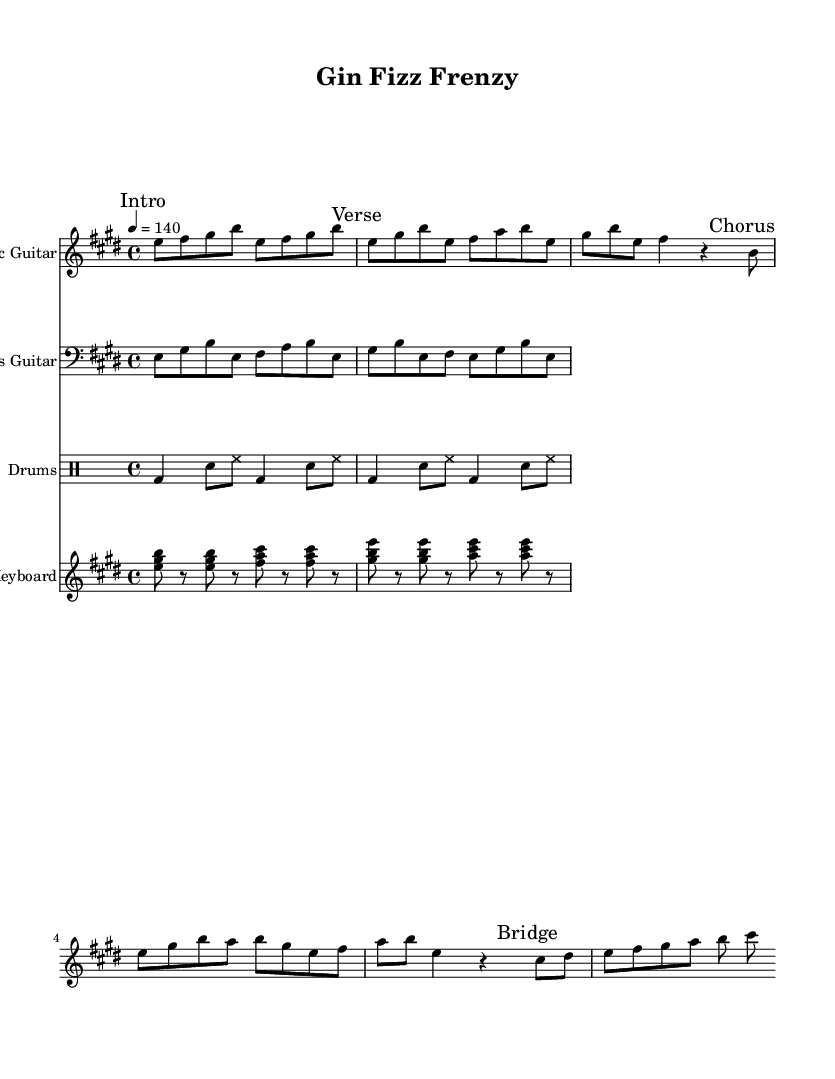What is the key signature of this music? The key signature is indicated before the staff and shows the presence of four sharps, meaning it is E major.
Answer: E major What is the time signature of this music? The time signature appears at the beginning of the score and is expressed as a fraction, indicating four beats in a measure, which is 4/4.
Answer: 4/4 What is the tempo marking of this piece? The tempo marking appears in the header section as "4 = 140," indicating a speed of 140 beats per minute.
Answer: 140 How many distinct sections are there in this piece? The music contains four distinct marked sections: Intro, Verse, Chorus, and Bridge, as indicated in the guitar part annotations.
Answer: Four What is the tempo indication of the Chorus section? The tempo remains constant at 140 beats per minute throughout the piece; the chorus section does not change this tempo.
Answer: 140 What instrument is primarily featured in the melody? The melody is primarily carried out by the Electric Guitar part, as indicated by the staff heading.
Answer: Electric Guitar What type of rhythm pattern is used in the drum part? The drum part follows a standard rock rhythm characterized by bass drum and snare hits, alternating with hi-hat, as shown in the drum notation.
Answer: Rock rhythm 